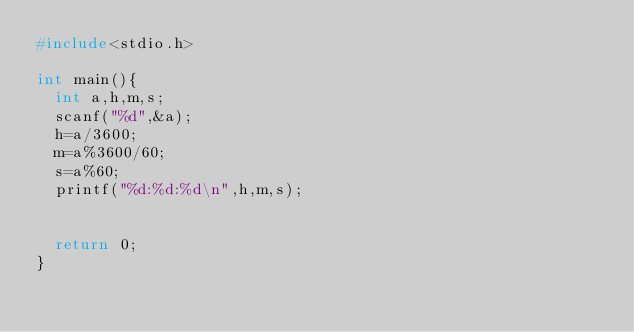Convert code to text. <code><loc_0><loc_0><loc_500><loc_500><_C_>#include<stdio.h>

int main(){
	int a,h,m,s;
	scanf("%d",&a);
	h=a/3600;
	m=a%3600/60;
	s=a%60;
	printf("%d:%d:%d\n",h,m,s);
	
	
	return 0;
}</code> 